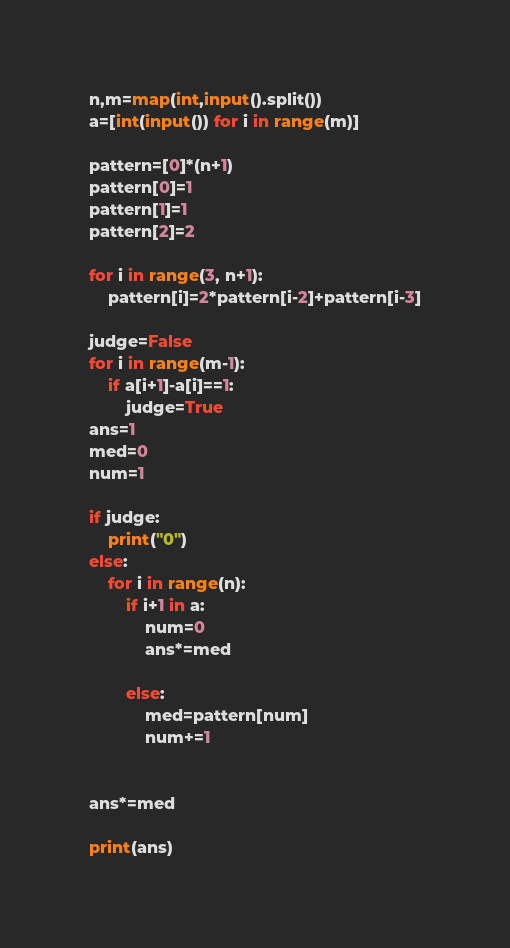<code> <loc_0><loc_0><loc_500><loc_500><_Python_>n,m=map(int,input().split())
a=[int(input()) for i in range(m)]

pattern=[0]*(n+1)
pattern[0]=1
pattern[1]=1
pattern[2]=2

for i in range(3, n+1):
    pattern[i]=2*pattern[i-2]+pattern[i-3]

judge=False
for i in range(m-1):
    if a[i+1]-a[i]==1:
        judge=True
ans=1
med=0
num=1

if judge:
    print("0")
else:
    for i in range(n):
        if i+1 in a:
            num=0
            ans*=med
    
        else:
            med=pattern[num]
            num+=1


ans*=med

print(ans)
</code> 